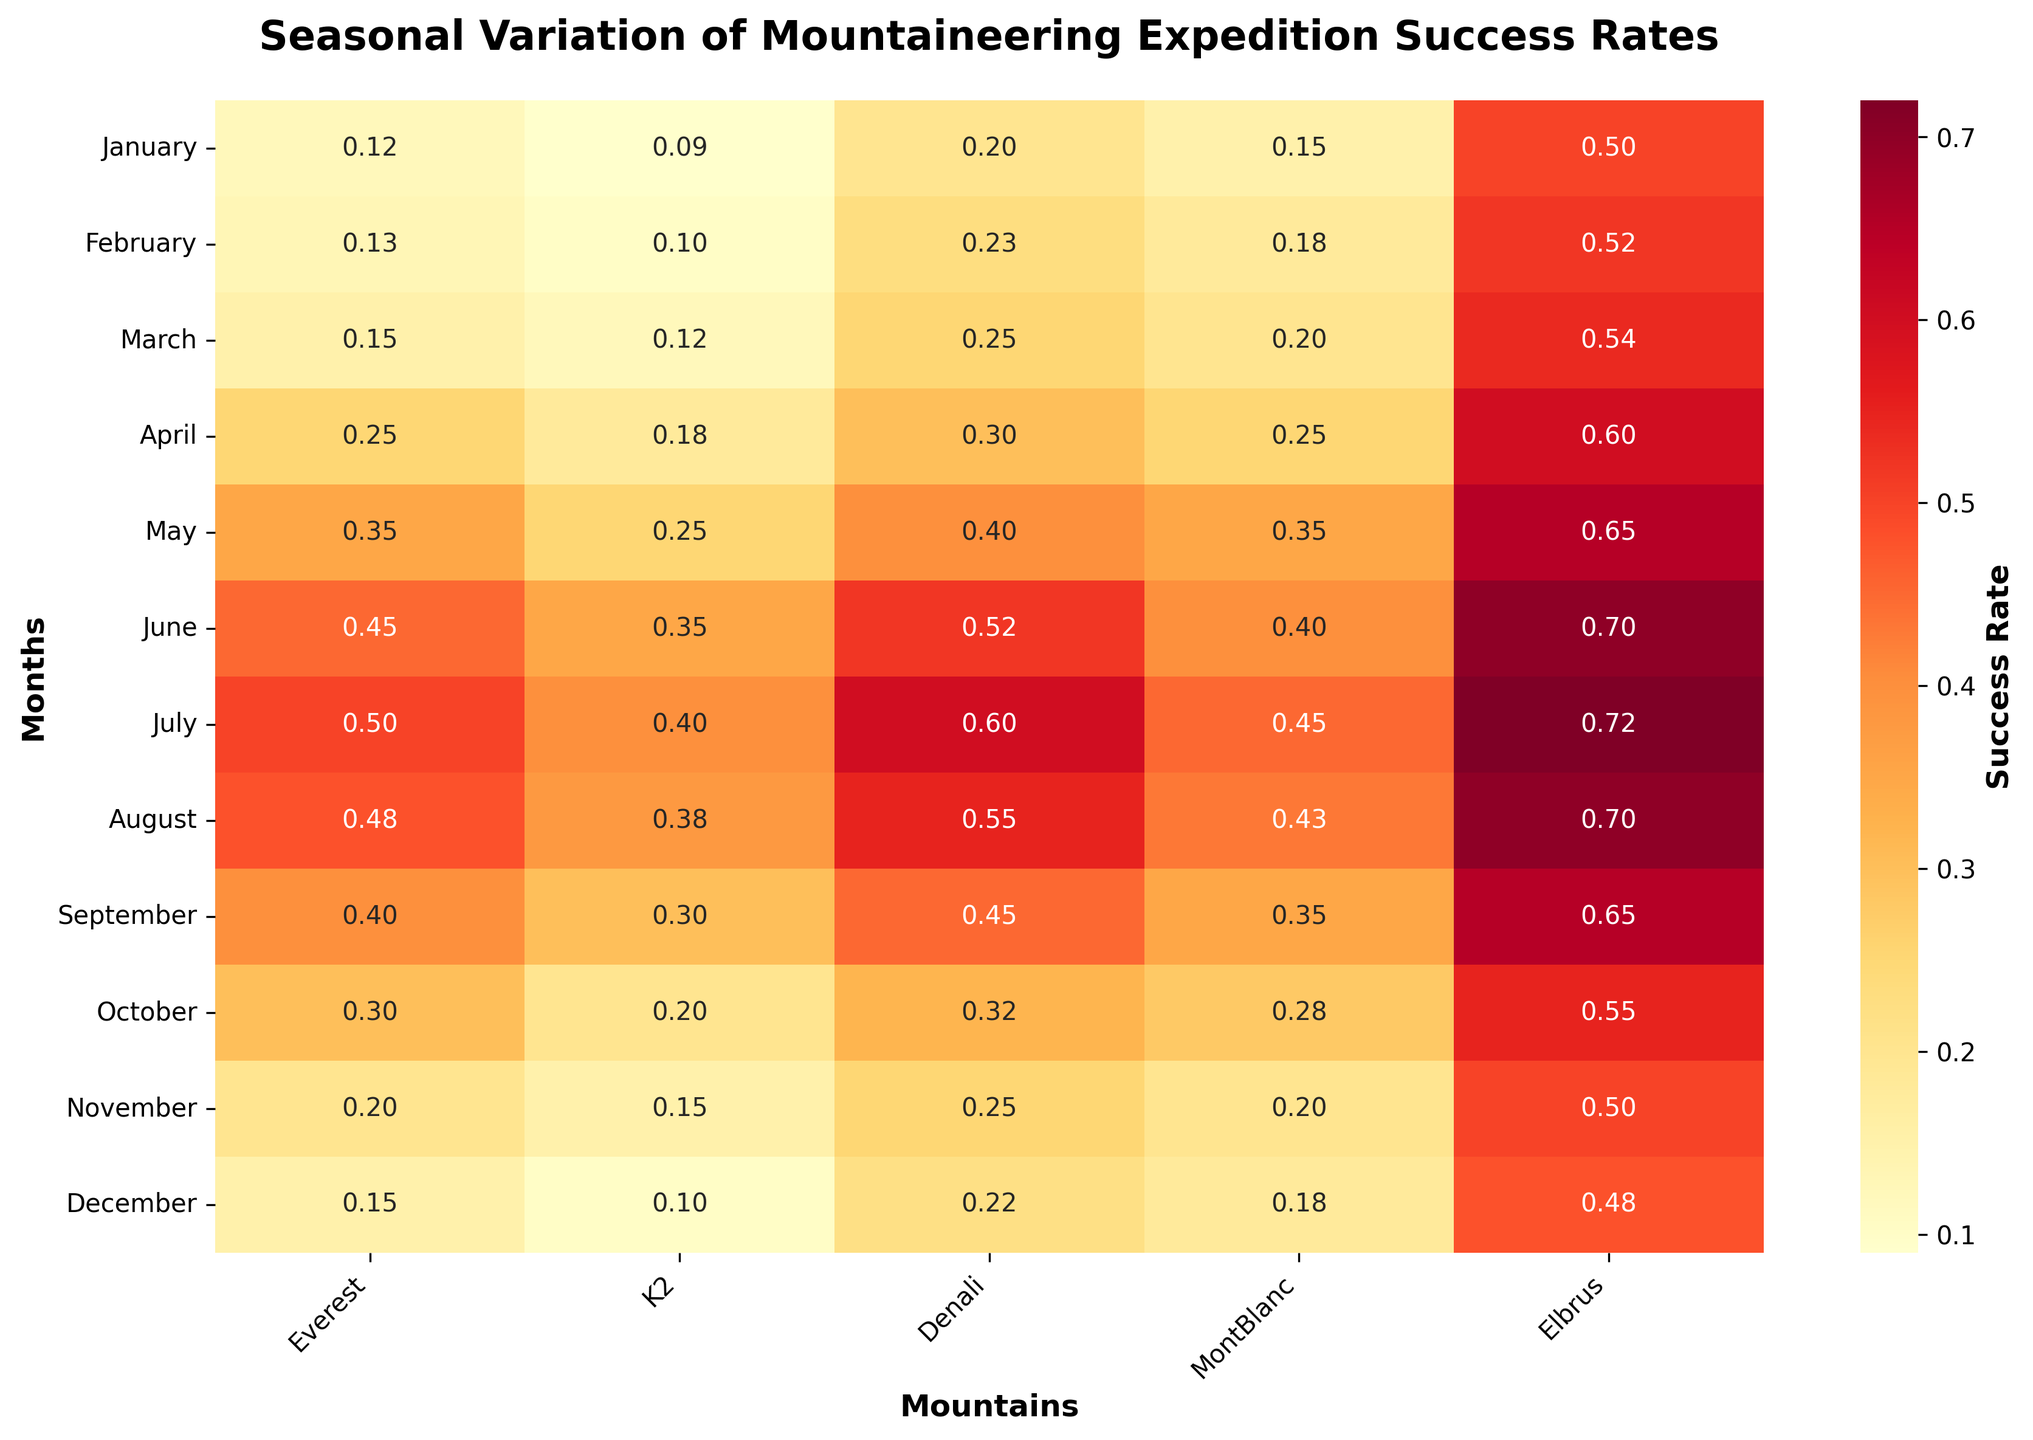What is the title of the heatmap? The title can be found at the top of the figure, usually in a larger font. In this case, the title reads "Seasonal Variation of Mountaineering Expedition Success Rates".
Answer: Seasonal Variation of Mountaineering Expedition Success Rates Which mountain has the highest success rate in July? Look at the July row and identify the highest value. The mountain with the highest value in July is "Denali" with a success rate of 0.60.
Answer: Denali In which month does K2 have the lowest success rate? Look at the column corresponding to K2 and identify the lowest value. The lowest success rate for K2 is in January and December, both with a success rate of 0.09.
Answer: January, December Which month shows the greatest overall success rate for all mountains? Compare the cells across all months and identify the month with the highest value. The overall highest success rate is found in July for Everest with a rate of 0.60.
Answer: July What is the difference in success rates for Everest between January and July? Subtract the success rate of Everest in January (0.12) from that of July (0.50). The difference is 0.50 - 0.12 = 0.38.
Answer: 0.38 Which months have an increasing trend in success rates for Mont Blanc? Observe the success rates of Mont Blanc month by month. The success rates show an increase from January (0.15) to May (0.35), which is an increasing trend.
Answer: January to May What is the average success rate of Elbrus across the year? Sum the monthly success rates for Elbrus (0.5 + 0.52 + 0.54 + 0.6 + 0.65 + 0.7 + 0.72 + 0.7 + 0.65 + 0.55 + 0.5 + 0.48) and divide by 12. The average is (7.11) / 12 = 0.5925.
Answer: 0.59 Which mountain shows the least variation in success rates across the year? Examine the success rates for each mountain and find the one with the smallest range. Mont Blanc has a range of 0.45 - 0.15 = 0.30, which is the smallest variation.
Answer: Mont Blanc In which month do all five mountains have their highest success rates simultaneously? Compare the columns for each mountain to check when all mountains have their highest values. There is no month where all mountains reach their peak simultaneously, but July has high values for most of the mountains.
Answer: None What patterns can you see for Everest's success rates across different seasons? Check the values for Everest across different seasons (winter: Dec-Feb, spring: Mar-May, summer: Jun-Aug, fall: Sep-Nov). There is a general increasing trend from winter to summer, peaking in summer and decreasing towards fall.
Answer: Increasing until summer, peaking in summer, then decreasing 